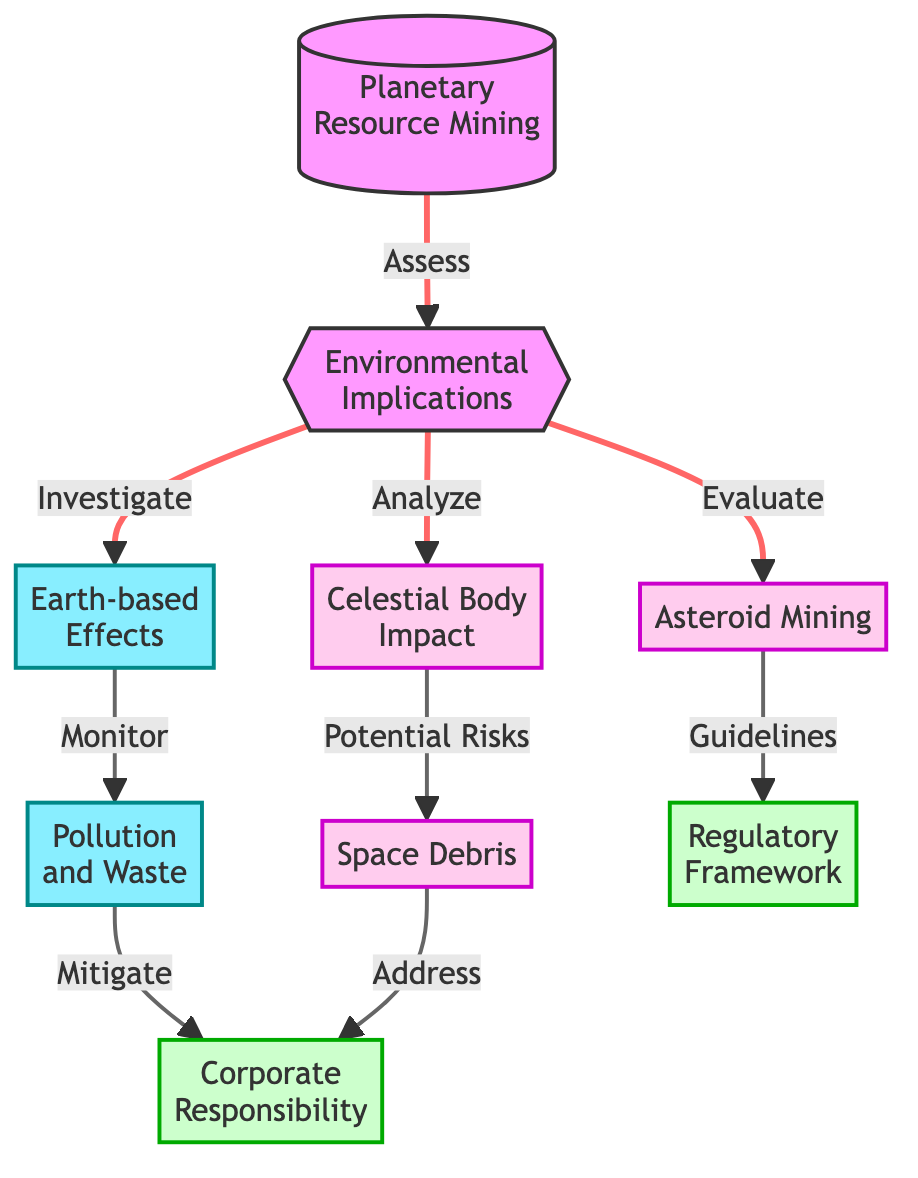What is the main topic of this diagram? The primary node labeled "Planetary Resource Mining" identifies the central theme of the diagram, indicating that it covers discussions and issues related to mining resources from celestial bodies.
Answer: Planetary Resource Mining How many primary implications are there for planetary resource mining? There are three primary implications stemming from the central node, as depicted by nodes branching from "Environmental Implications" which include "Asteroid Mining," "Celestial Body Impact," and "Earth-based Effects."
Answer: 3 What are the two environmental effects related to "Earth-based Effects"? The "Earth-based Effects" node connects to two nodes, "Pollution and Waste" and "Corporate Responsibility," illustrating the potential impacts on Earth from mining activities.
Answer: Pollution and Waste, Corporate Responsibility What is the relationship between "Asteroid Mining" and "Regulatory Framework"? In the diagram, "Asteroid Mining" does not connect directly to "Regulatory Framework," but "Environmental Implications" connects to "Asteroid Mining," which then leads to "Guidelines," indicating a regulatory aspect related to safe practices in asteroid mining.
Answer: Guidelines What potential risk is associated with "Celestial Body Impact"? The "Celestial Body Impact" node leads to "Space Debris," which signifies that one potential risk of impacting celestial bodies includes the creation of debris in space from such activities.
Answer: Space Debris Which node is responsible for monitoring pollution? The node "Earth-based Effects" connects to "Pollution and Waste," indicating that monitoring efforts would be directed towards this specific type of waste generated by mining activities on Earth.
Answer: Pollution and Waste How does "Pollution and Waste" relate to "Corporate Responsibility"? "Pollution and Waste" connects to "Corporate Responsibility," suggesting that corporate entities are expected to address issues arising from pollution linked to their mining activities, highlighting accountability for environmental impact.
Answer: Corporate Responsibility What environmental implication involves evaluating potential risks? The node "Celestial Body Impact" is related to potential risks and is listed as part of the evaluation process under environmental implications, focusing on the various environmental effects caused by mining operations.
Answer: Potential Risks 